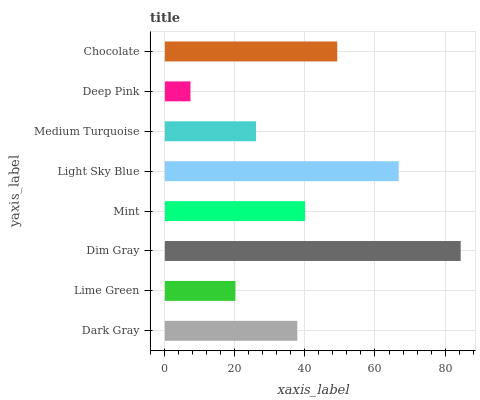Is Deep Pink the minimum?
Answer yes or no. Yes. Is Dim Gray the maximum?
Answer yes or no. Yes. Is Lime Green the minimum?
Answer yes or no. No. Is Lime Green the maximum?
Answer yes or no. No. Is Dark Gray greater than Lime Green?
Answer yes or no. Yes. Is Lime Green less than Dark Gray?
Answer yes or no. Yes. Is Lime Green greater than Dark Gray?
Answer yes or no. No. Is Dark Gray less than Lime Green?
Answer yes or no. No. Is Mint the high median?
Answer yes or no. Yes. Is Dark Gray the low median?
Answer yes or no. Yes. Is Dim Gray the high median?
Answer yes or no. No. Is Mint the low median?
Answer yes or no. No. 